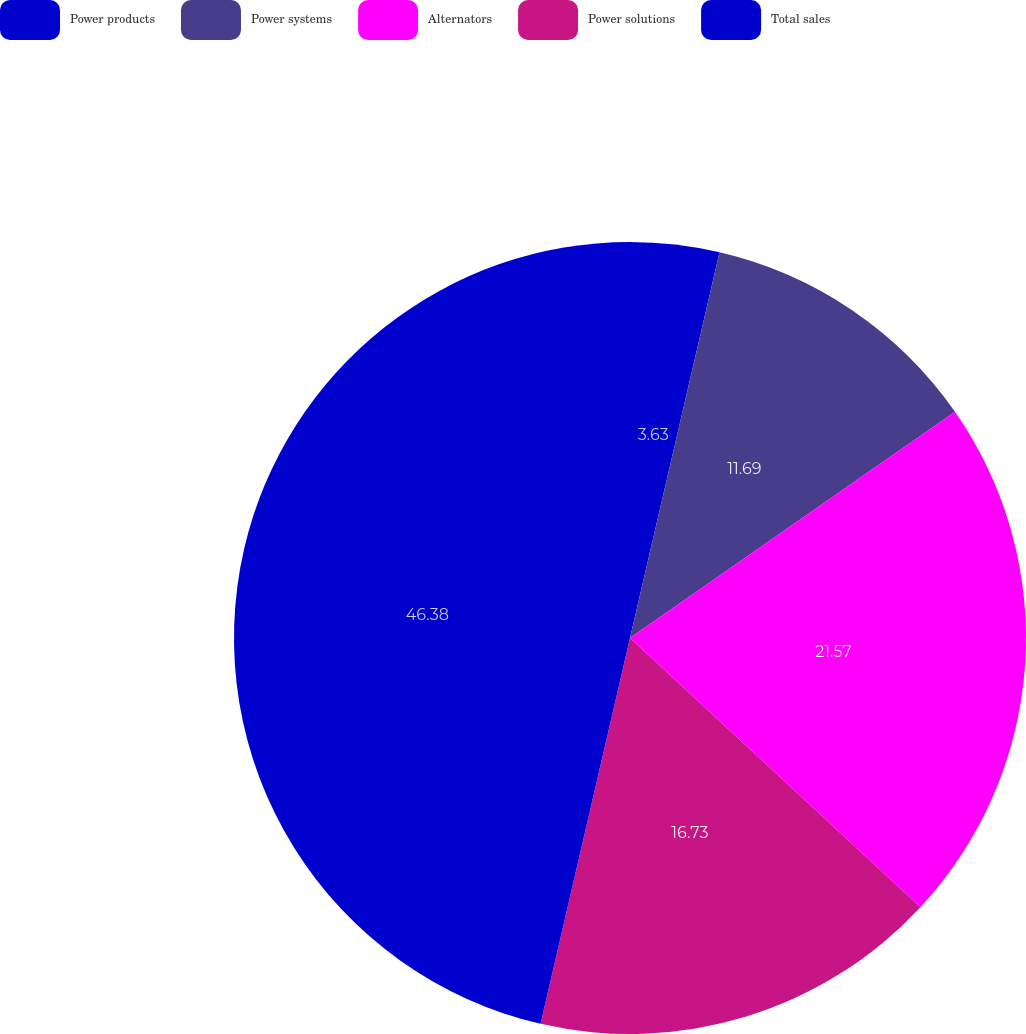Convert chart to OTSL. <chart><loc_0><loc_0><loc_500><loc_500><pie_chart><fcel>Power products<fcel>Power systems<fcel>Alternators<fcel>Power solutions<fcel>Total sales<nl><fcel>3.63%<fcel>11.69%<fcel>21.57%<fcel>16.73%<fcel>46.37%<nl></chart> 